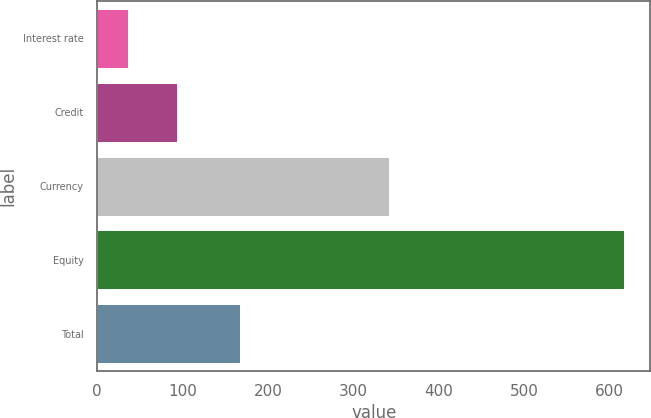Convert chart. <chart><loc_0><loc_0><loc_500><loc_500><bar_chart><fcel>Interest rate<fcel>Credit<fcel>Currency<fcel>Equity<fcel>Total<nl><fcel>36<fcel>94.1<fcel>342<fcel>617<fcel>167<nl></chart> 